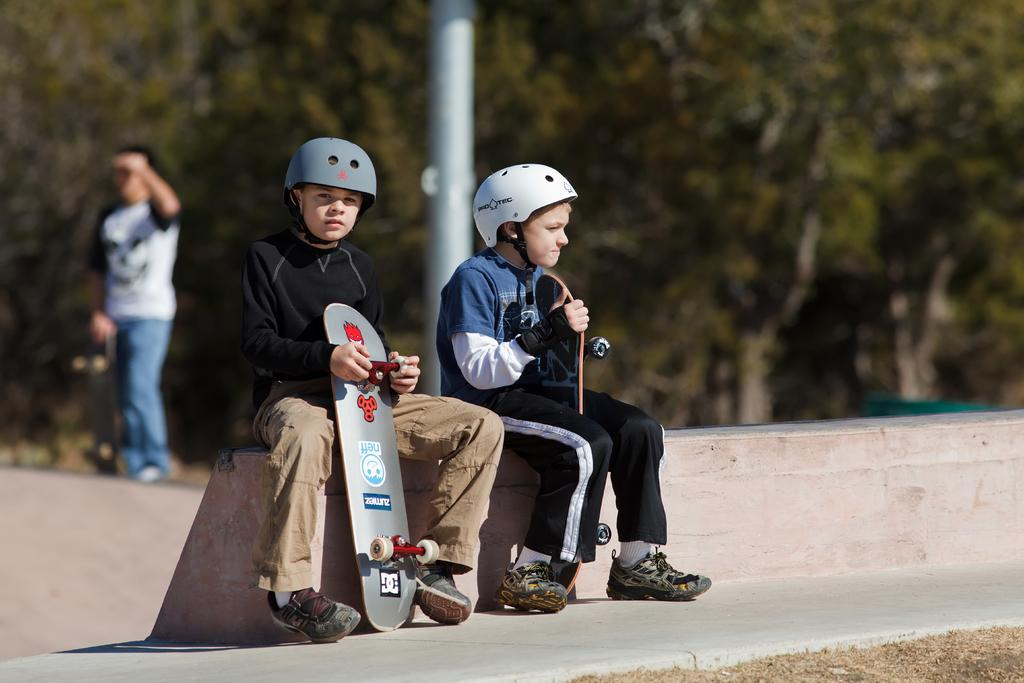How many kids are in the image? There are two kids in the image. What are the kids doing in the image? The kids are sitting on a wall. What are the kids wearing on their heads? The kids are wearing helmets. What are the kids holding in their hands? The kids are holding skateboards in their hands. What can be seen in the background of the image? There are trees visible in the background of the image. What type of ship can be seen sailing on the roof in the image? There is no ship or roof present in the image; it features two kids sitting on a wall while wearing helmets and holding skateboards. 